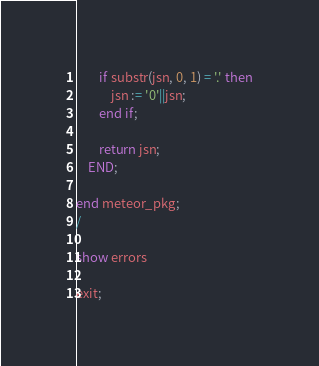<code> <loc_0><loc_0><loc_500><loc_500><_SQL_>		if substr(jsn, 0, 1) = '.' then
			jsn := '0'||jsn;
		end if;

		return jsn;
	END;

end meteor_pkg;
/

show errors

exit;

</code> 